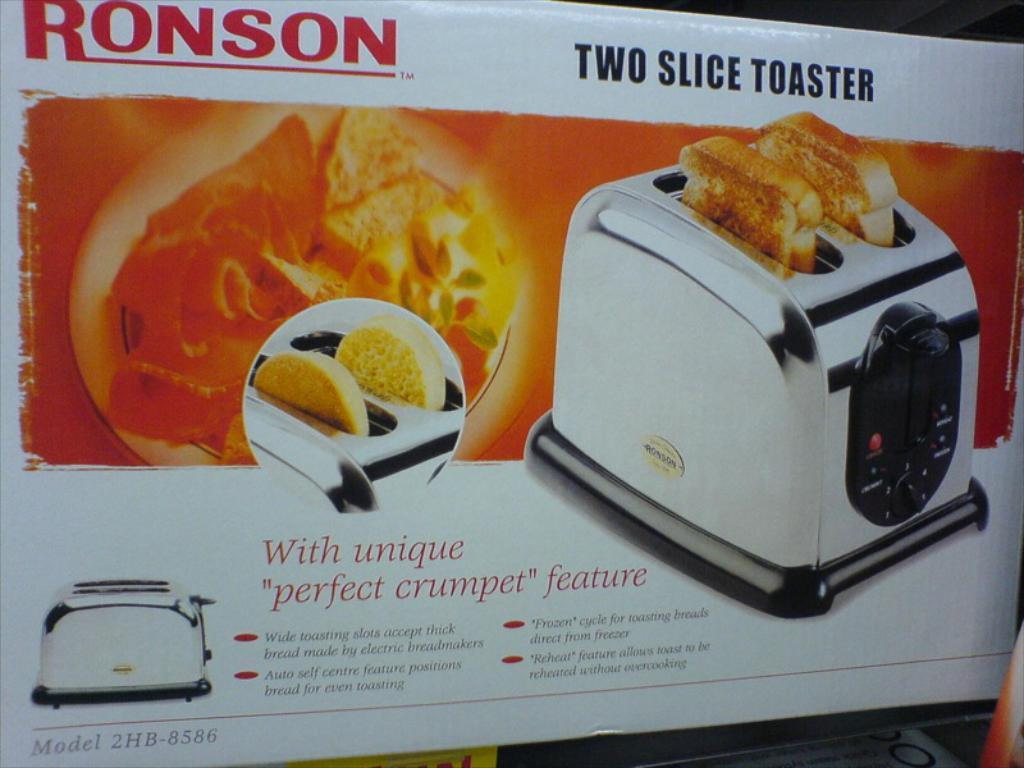<image>
Write a terse but informative summary of the picture. A box contains a Ronson two slice toaster. 